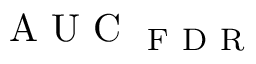Convert formula to latex. <formula><loc_0><loc_0><loc_500><loc_500>A U C _ { F D R }</formula> 